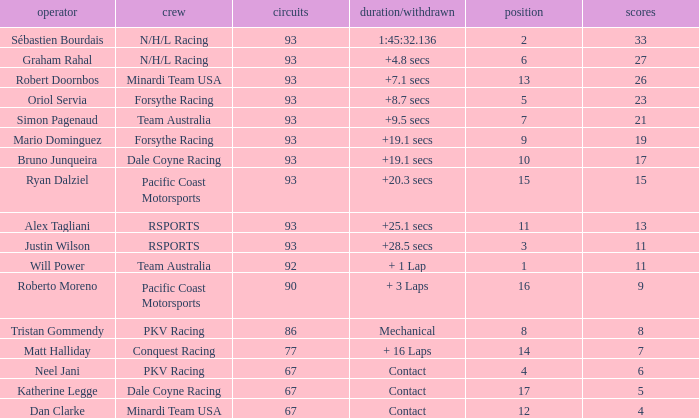Could you parse the entire table as a dict? {'header': ['operator', 'crew', 'circuits', 'duration/withdrawn', 'position', 'scores'], 'rows': [['Sébastien Bourdais', 'N/H/L Racing', '93', '1:45:32.136', '2', '33'], ['Graham Rahal', 'N/H/L Racing', '93', '+4.8 secs', '6', '27'], ['Robert Doornbos', 'Minardi Team USA', '93', '+7.1 secs', '13', '26'], ['Oriol Servia', 'Forsythe Racing', '93', '+8.7 secs', '5', '23'], ['Simon Pagenaud', 'Team Australia', '93', '+9.5 secs', '7', '21'], ['Mario Dominguez', 'Forsythe Racing', '93', '+19.1 secs', '9', '19'], ['Bruno Junqueira', 'Dale Coyne Racing', '93', '+19.1 secs', '10', '17'], ['Ryan Dalziel', 'Pacific Coast Motorsports', '93', '+20.3 secs', '15', '15'], ['Alex Tagliani', 'RSPORTS', '93', '+25.1 secs', '11', '13'], ['Justin Wilson', 'RSPORTS', '93', '+28.5 secs', '3', '11'], ['Will Power', 'Team Australia', '92', '+ 1 Lap', '1', '11'], ['Roberto Moreno', 'Pacific Coast Motorsports', '90', '+ 3 Laps', '16', '9'], ['Tristan Gommendy', 'PKV Racing', '86', 'Mechanical', '8', '8'], ['Matt Halliday', 'Conquest Racing', '77', '+ 16 Laps', '14', '7'], ['Neel Jani', 'PKV Racing', '67', 'Contact', '4', '6'], ['Katherine Legge', 'Dale Coyne Racing', '67', 'Contact', '17', '5'], ['Dan Clarke', 'Minardi Team USA', '67', 'Contact', '12', '4']]} What is the grid for the Minardi Team USA with laps smaller than 90? 12.0. 